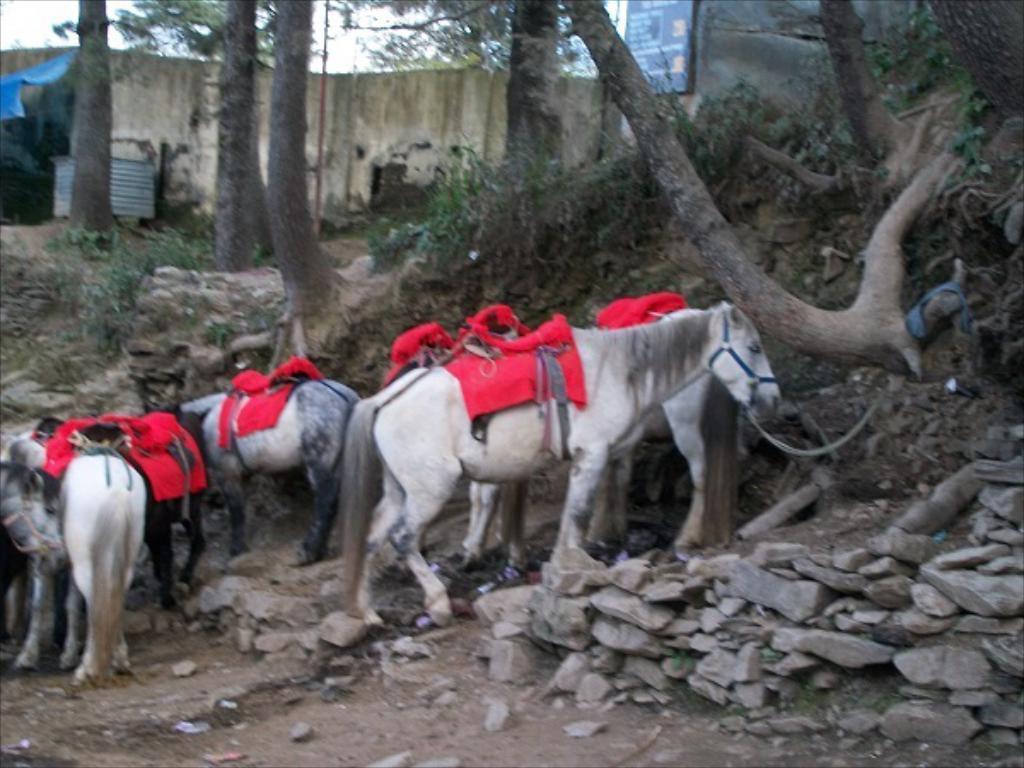In one or two sentences, can you explain what this image depicts? In this picture we can see many horse. On the their back we can see red color cloth. They are standing near to the stones. On the right we can see grass and plants. In the background we can see a barrel near to the wall. At the top we can see tree and pole. In the top right there is a banner. In the top left corner there is a sky. 